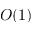Convert formula to latex. <formula><loc_0><loc_0><loc_500><loc_500>O ( 1 )</formula> 